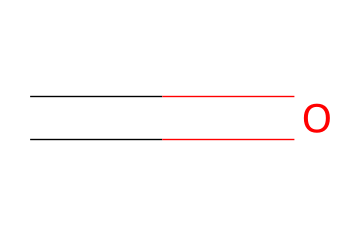What is the molecular formula of this compound? The SMILES representation "C=O" indicates that there is one carbon atom (C) and one oxygen atom (O) involved in the structure. Therefore, the molecular formula combines these atoms, resulting in CH2O, which corresponds to formaldehyde.
Answer: CH2O How many atoms are in this compound? In the molecular formula CH2O, there are 3 atoms total: 1 carbon atom, 2 hydrogen atoms (implied by the formula), and 1 oxygen atom. Adding them gives a total of 3 atoms.
Answer: 3 What type of bond is indicated in the structure? The "=" sign in the SMILES representation indicates a double bond between carbon and oxygen. This is characteristic of carbonyl groups found in aldehydes and ketones.
Answer: double bond Is formaldehyde classified as a solid, liquid, or gas at room temperature? Formaldehyde is a gas at room temperature, specifically known to be a colorless gas with a pungent odor. It is usually found in the gaseous state under normal atmospheric conditions.
Answer: gas What type of compound is formaldehyde classified as? Formaldehyde is classified as an aldehyde; this classification is due to the presence of the carbonyl (C=O) group directly attached to a carbon atom that is also bonded to a hydrogen atom.
Answer: aldehyde How many functional groups does formaldehyde have? In the structure of formaldehyde, there is one functional group present, which is the carbonyl group. It plays a crucial role in the chemical reactions and properties of aldehydes.
Answer: one What is the primary use of formaldehyde in construction materials? Formaldehyde is primarily used as a preservative and in the production of resins and solvents, contributing to its application in various building materials like pressed wood products.
Answer: preservatives 